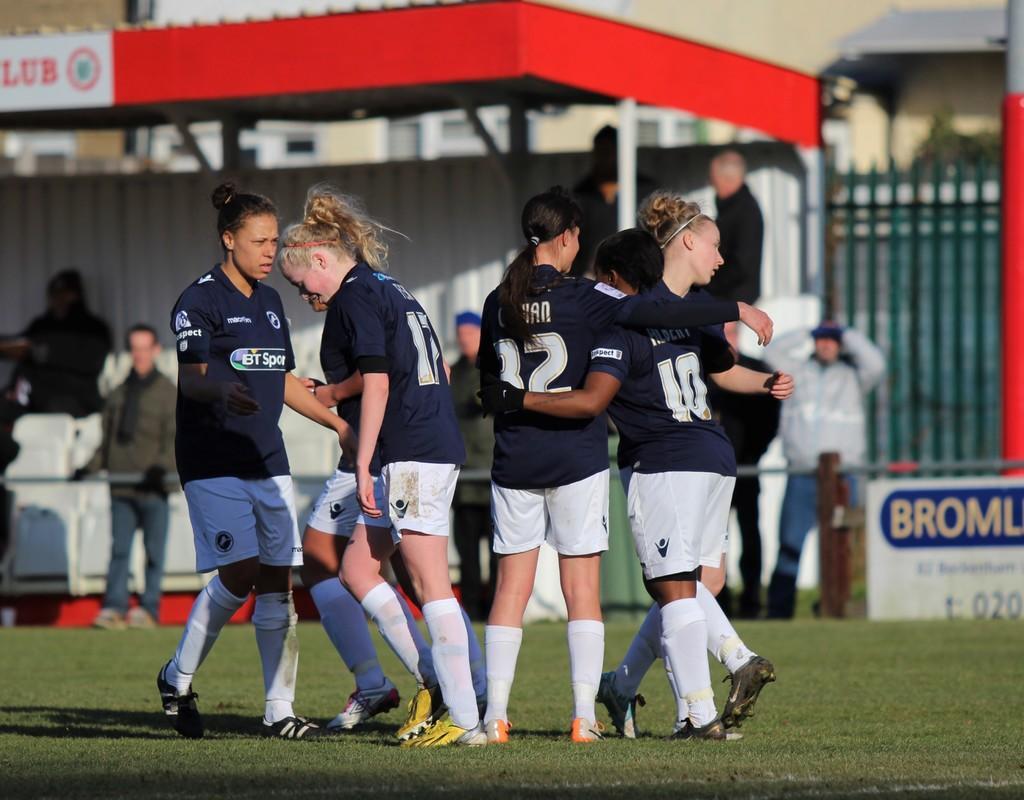Can you describe this image briefly? In this image there are players in a ground, in the background people are standing under a shed and it is blurred. 